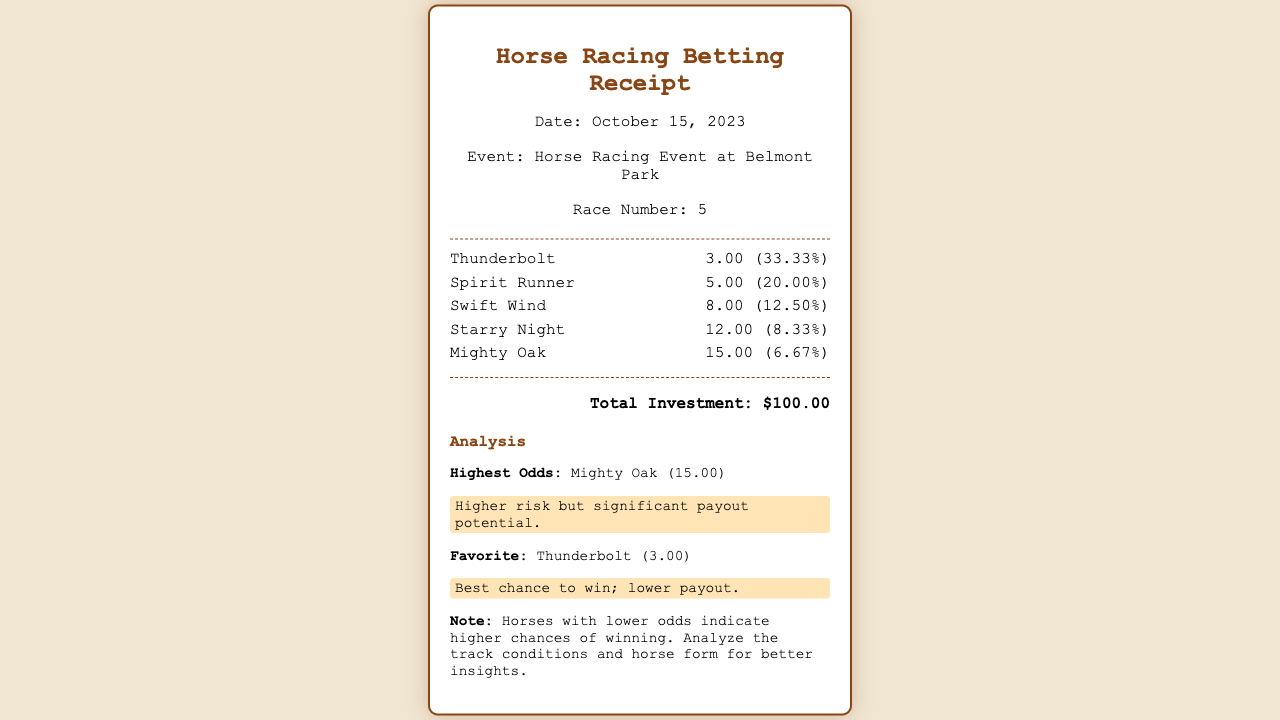What is the event name? The event name is mentioned in the header of the document, which indicates where the race is taking place.
Answer: Horse Racing Event at Belmont Park What is the race number? The race number is listed in the header section of the receipt.
Answer: 5 Who is the favorite horse? The favorite horse is indicated in the analysis section where it mentions the horse with the lowest odds.
Answer: Thunderbolt What are the odds for Mighty Oak? The odds for each horse are listed next to their names in the horse list section.
Answer: 15.00 What is the total investment amount? The total investment amount is provided clearly in the total section of the document.
Answer: $100.00 What percentage chance does Spirit Runner have of winning? The implied probability for each horse is shown in parentheses next to their odds.
Answer: 20.00% Which horse has the highest odds? The highest odds are explicitly stated in the analysis section.
Answer: Mighty Oak (15.00) What should you analyze for better insights according to the note? The note provides a suggestion for what additional factors to consider when placing bets.
Answer: Track conditions and horse form 